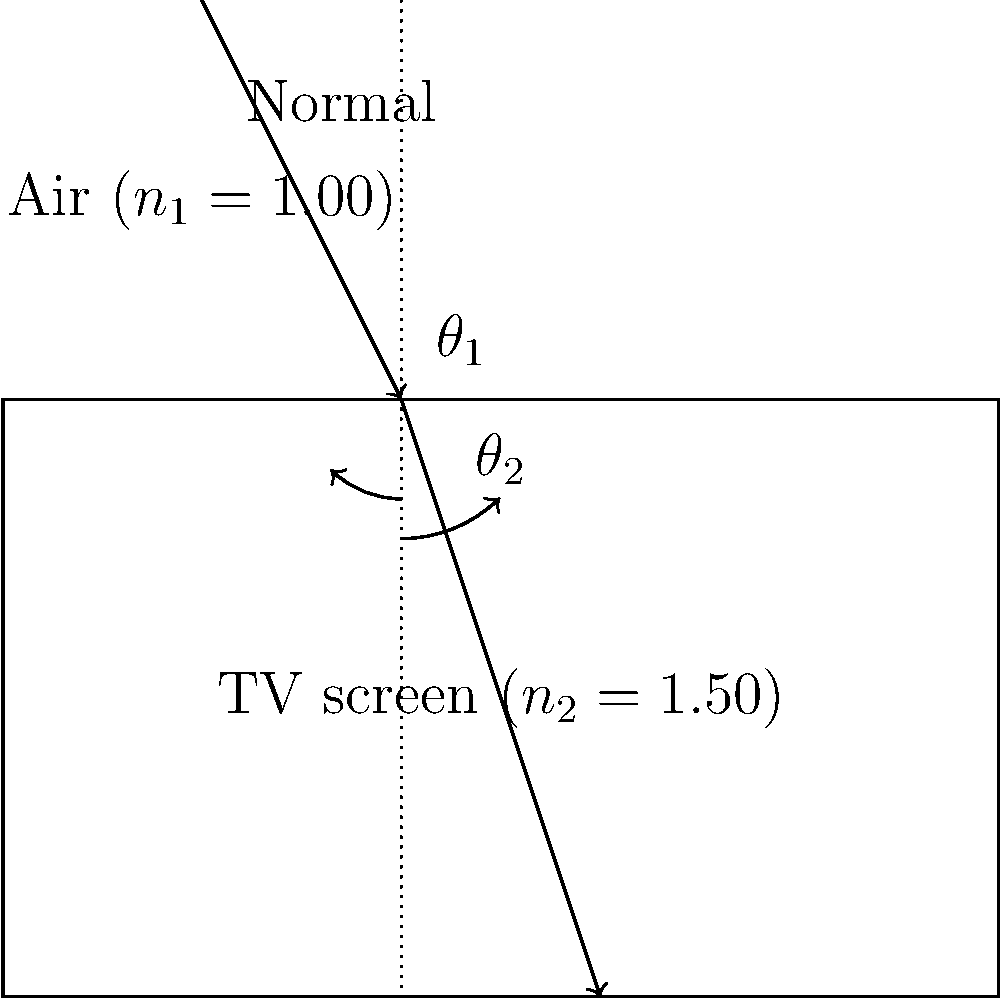While watching a rerun of your favorite 90s sitcom on your old TV, you notice how the light reflects off the screen. If a ray of light hits the TV screen at an angle of 30° to the normal, and the refractive index of the TV screen material is 1.50, what is the angle of refraction inside the TV screen? (Assume the refractive index of air is 1.00) To solve this problem, we'll use Snell's Law, which describes how light refracts when passing from one medium to another:

$$n_1 \sin(\theta_1) = n_2 \sin(\theta_2)$$

Where:
$n_1$ = refractive index of the first medium (air)
$n_2$ = refractive index of the second medium (TV screen)
$\theta_1$ = angle of incidence
$\theta_2$ = angle of refraction

Given:
$n_1 = 1.00$ (air)
$n_2 = 1.50$ (TV screen)
$\theta_1 = 30°$

Step 1: Substitute the known values into Snell's Law:
$$(1.00) \sin(30°) = (1.50) \sin(\theta_2)$$

Step 2: Simplify the left side of the equation:
$$0.5 = 1.50 \sin(\theta_2)$$

Step 3: Solve for $\sin(\theta_2)$:
$$\sin(\theta_2) = \frac{0.5}{1.50} = 0.3333$$

Step 4: Take the inverse sine (arcsin) of both sides to find $\theta_2$:
$$\theta_2 = \arcsin(0.3333)$$

Step 5: Calculate the final result:
$$\theta_2 \approx 19.47°$$

Therefore, the angle of refraction inside the TV screen is approximately 19.47°.
Answer: 19.47° 